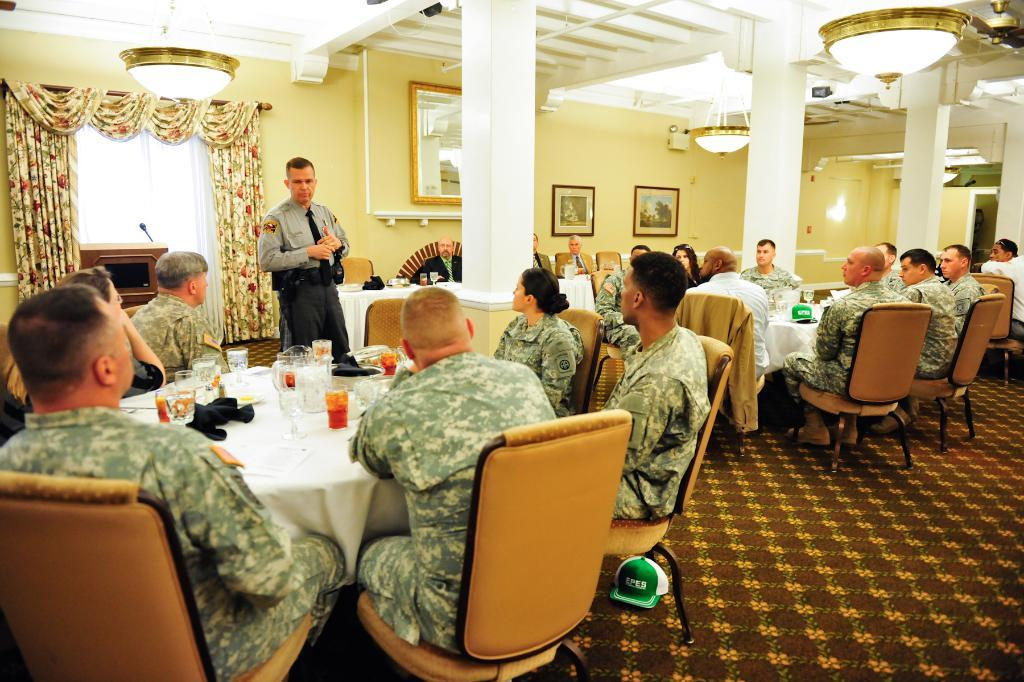What are the people in the image doing? The people in the image are sitting on chairs. Is there anyone standing in the image? Yes, there is a man standing in the image. What can be seen on the wall in the background of the image? There are frames on a wall in the background of the image. What type of window treatment is present in the image? There is a curtain on a window in the background of the image. What type of business is being conducted in the image? There is no indication of any business being conducted in the image; it simply shows people sitting on chairs and a man standing. 